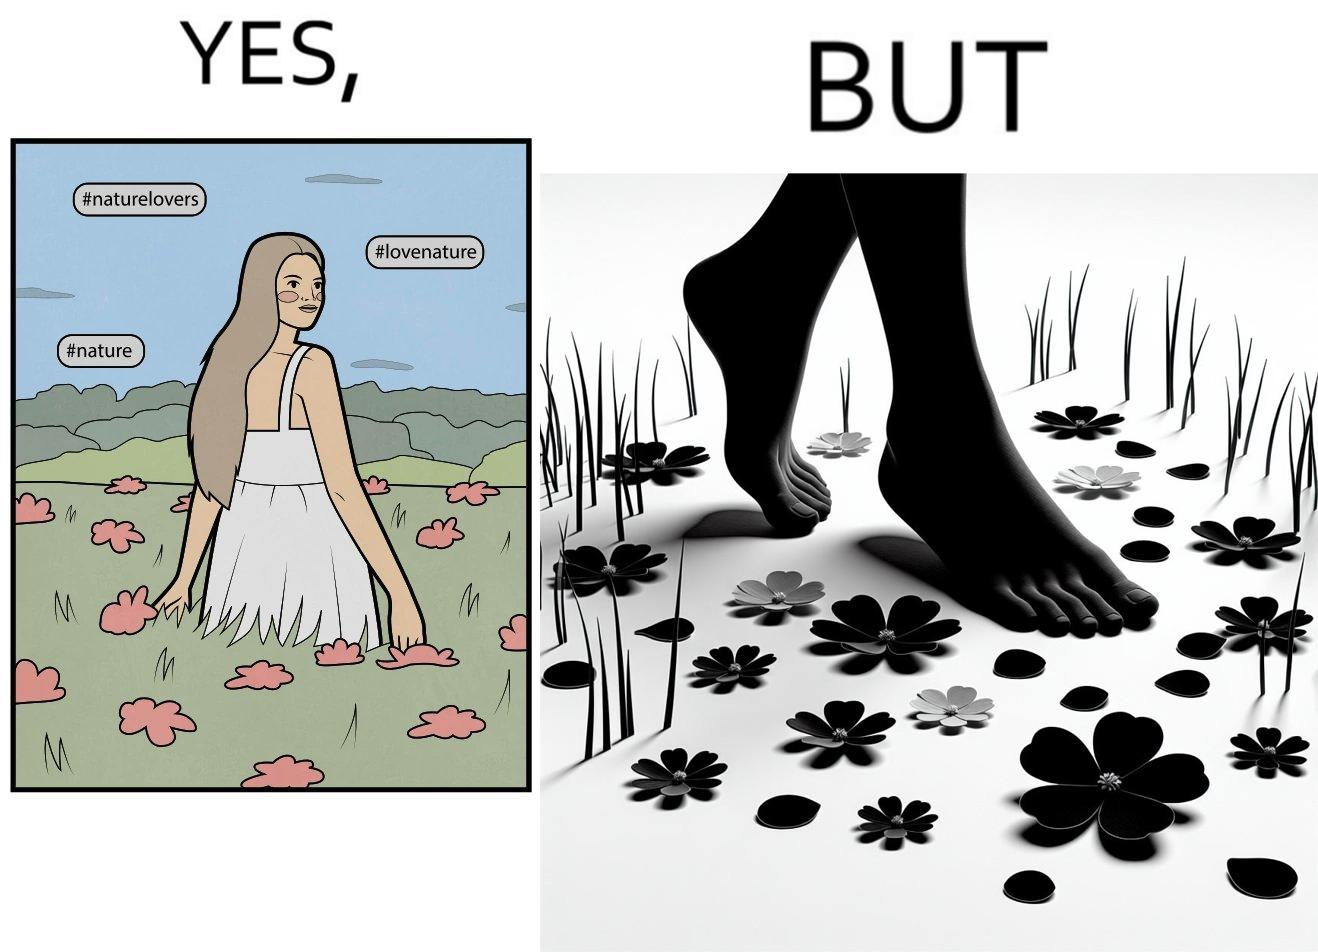Is this a satirical image? Yes, this image is satirical. 